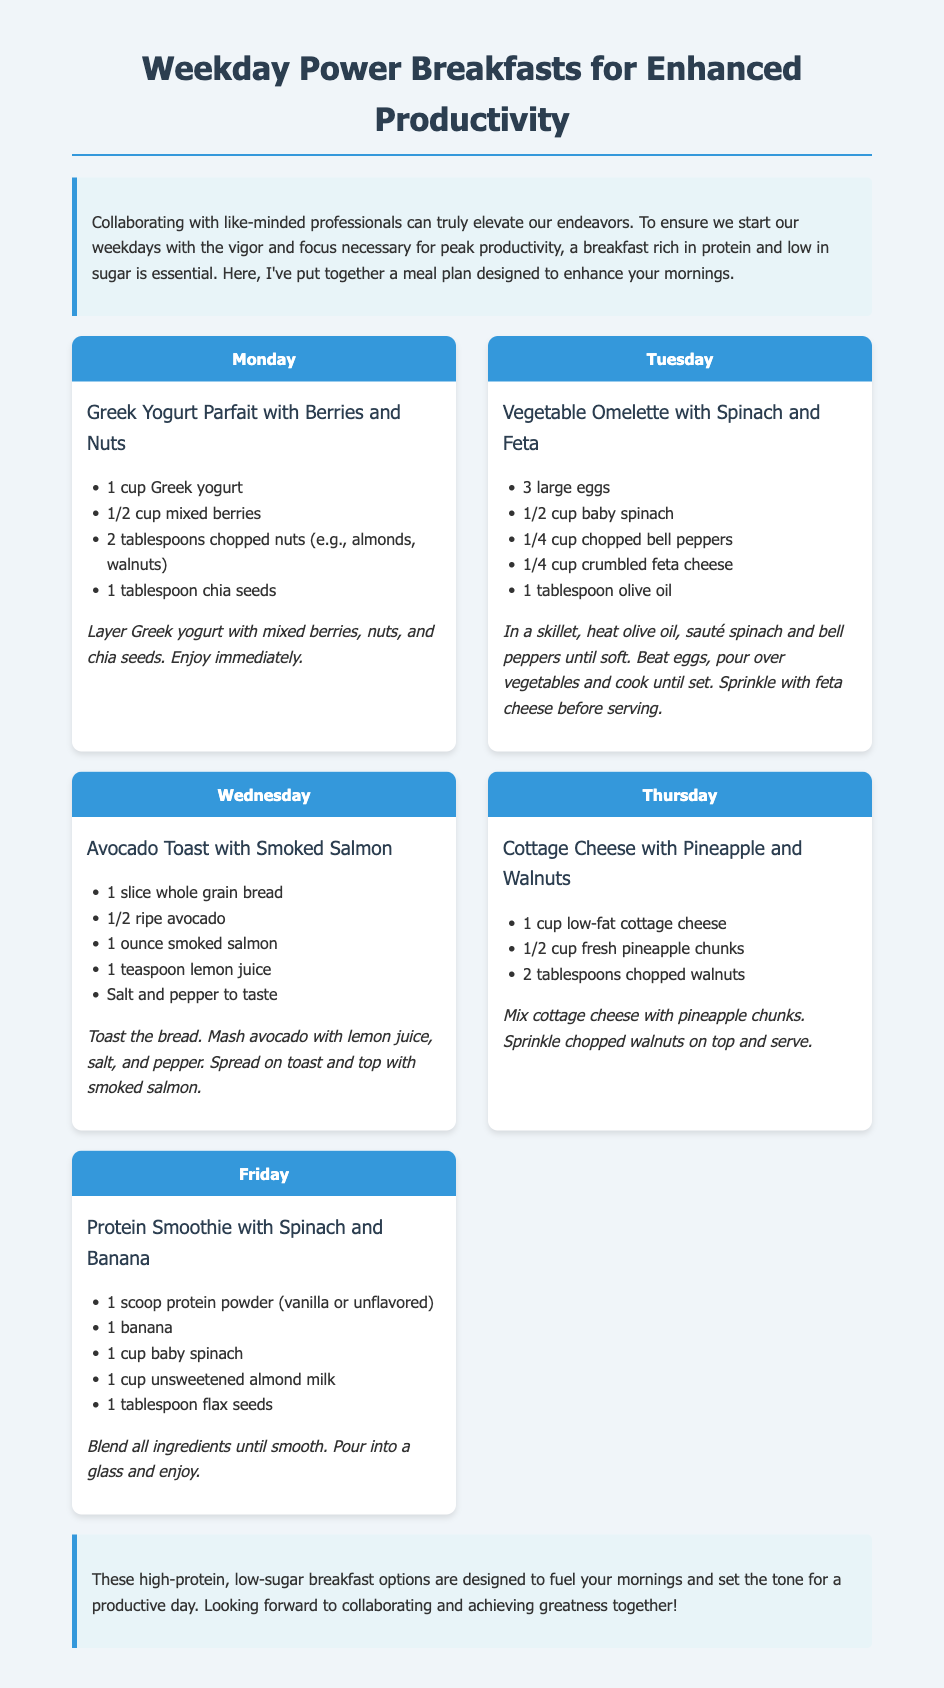What is the title of the meal plan? The title of the meal plan is prominently displayed at the top of the document.
Answer: Weekday Power Breakfasts for Enhanced Productivity How many types of breakfasts are presented in the plan? The meal plan lists breakfast options for each weekday from Monday to Friday, totaling five breakfasts.
Answer: Five What ingredients are used in the Greek Yogurt Parfait? The document lists the specific ingredients under the meal description for this breakfast option.
Answer: Greek yogurt, mixed berries, chopped nuts, chia seeds What day features the Vegetable Omelette? The day for this specific meal is clearly labeled at the top of its section.
Answer: Tuesday What is the main protein source in the Protein Smoothie? The Protein Smoothie section mentions the key protein ingredient.
Answer: Protein powder Which breakfast has a fruit component? This question requires reasoning among the options to find those that include fruit.
Answer: Cottage Cheese with Pineapple and Walnuts What is the preparation style for the Avocado Toast? The preparation method is described in the instructions for this breakfast.
Answer: Mash avocado and spread on toast What is the primary focus of the meal plan's introduction? The introduction summarizes the purpose and benefits of the breakfast plan.
Answer: Enhanced productivity What is included in the conclusion of the document? The conclusion wraps up the message of the meal plan and its intentions.
Answer: Fuel your mornings and set the tone for a productive day 